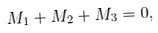Convert formula to latex. <formula><loc_0><loc_0><loc_500><loc_500>M _ { 1 } + M _ { 2 } + M _ { 3 } = 0 ,</formula> 